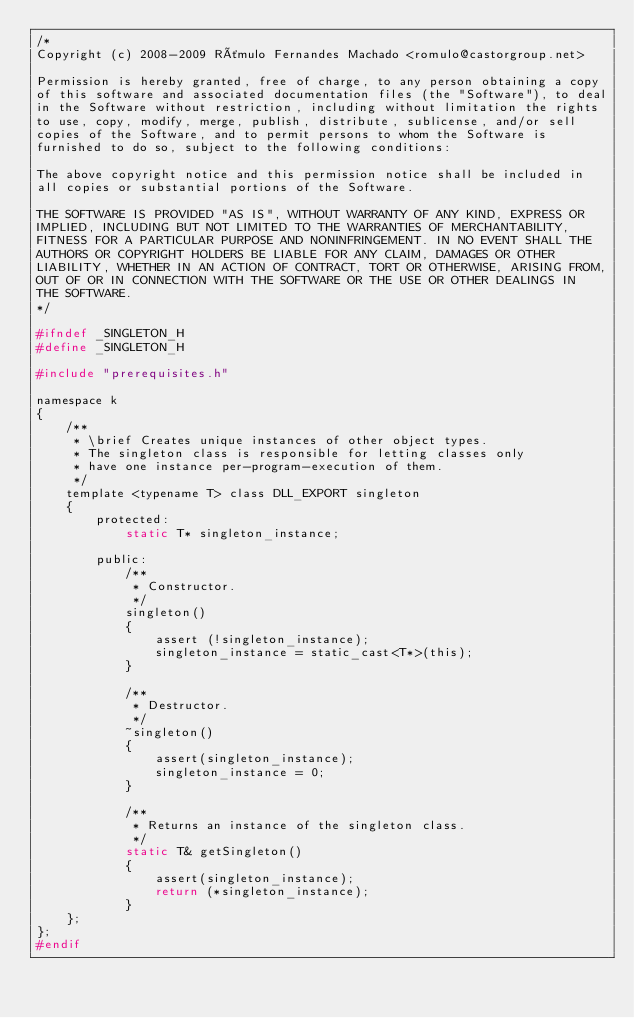Convert code to text. <code><loc_0><loc_0><loc_500><loc_500><_C_>/*
Copyright (c) 2008-2009 Rômulo Fernandes Machado <romulo@castorgroup.net>

Permission is hereby granted, free of charge, to any person obtaining a copy
of this software and associated documentation files (the "Software"), to deal
in the Software without restriction, including without limitation the rights
to use, copy, modify, merge, publish, distribute, sublicense, and/or sell
copies of the Software, and to permit persons to whom the Software is
furnished to do so, subject to the following conditions:

The above copyright notice and this permission notice shall be included in
all copies or substantial portions of the Software.

THE SOFTWARE IS PROVIDED "AS IS", WITHOUT WARRANTY OF ANY KIND, EXPRESS OR
IMPLIED, INCLUDING BUT NOT LIMITED TO THE WARRANTIES OF MERCHANTABILITY,
FITNESS FOR A PARTICULAR PURPOSE AND NONINFRINGEMENT. IN NO EVENT SHALL THE
AUTHORS OR COPYRIGHT HOLDERS BE LIABLE FOR ANY CLAIM, DAMAGES OR OTHER
LIABILITY, WHETHER IN AN ACTION OF CONTRACT, TORT OR OTHERWISE, ARISING FROM,
OUT OF OR IN CONNECTION WITH THE SOFTWARE OR THE USE OR OTHER DEALINGS IN
THE SOFTWARE.
*/

#ifndef _SINGLETON_H
#define _SINGLETON_H 

#include "prerequisites.h"

namespace k
{
	/**
	 * \brief Creates unique instances of other object types.
	 * The singleton class is responsible for letting classes only
	 * have one instance per-program-execution of them.
	 */
	template <typename T> class DLL_EXPORT singleton
	{
		protected:
			static T* singleton_instance;

    	public:
			/**
			 * Constructor.
			 */
			singleton()
			{
				assert (!singleton_instance);	
				singleton_instance = static_cast<T*>(this);
			}

			/**
			 * Destructor.
			 */
			~singleton()
        	{
				assert(singleton_instance);
				singleton_instance = 0;
			}

			/**
			 * Returns an instance of the singleton class.
			 */
        	static T& getSingleton()
			{		
				assert(singleton_instance);
				return (*singleton_instance); 
			}
	};
};
#endif
</code> 